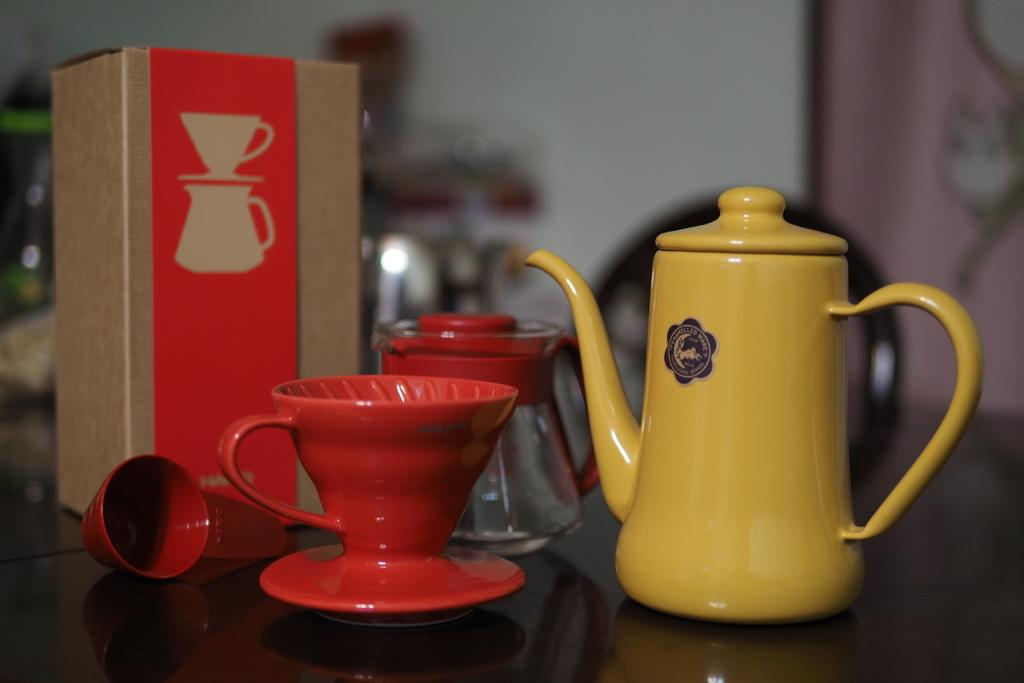What type of container is visible in the image? There is a mug in the image. Are there any other similar containers in the image? Yes, there are cups in the image. What else can be seen in the image besides the containers? There is a box in the image. Where are all the objects (mug, cups, and box) located in the image? All the objects are placed in one place in the image. How many dogs are visible in the image? There are no dogs present in the image. What type of material is used to lead the cats in the image? There are no cats or any material for leading them present in the image. 